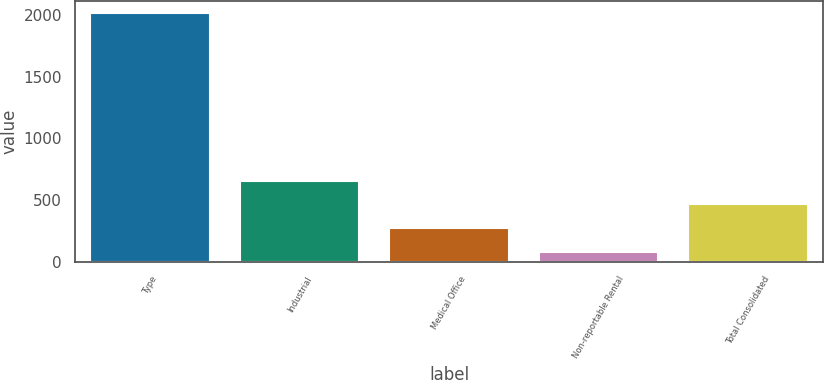Convert chart. <chart><loc_0><loc_0><loc_500><loc_500><bar_chart><fcel>Type<fcel>Industrial<fcel>Medical Office<fcel>Non-reportable Rental<fcel>Total Consolidated<nl><fcel>2016<fcel>658.56<fcel>270.72<fcel>76.8<fcel>464.64<nl></chart> 